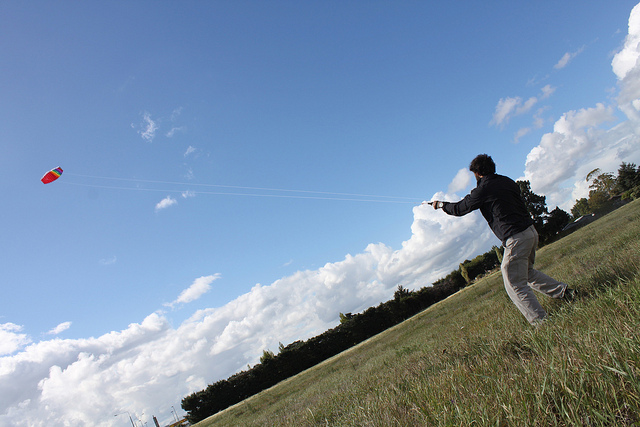<image>What are the horses doing on the hill? There are no horses on the hill in the image. What color is the frisbee? There is no frisbee in the image. However, it could be red or red and white. What are the horses doing on the hill? I don't know what the horses are doing on the hill. It can be seen playing, grazing, standing, or galloping. What color is the frisbee? It can be seen that the frisbee is red. 